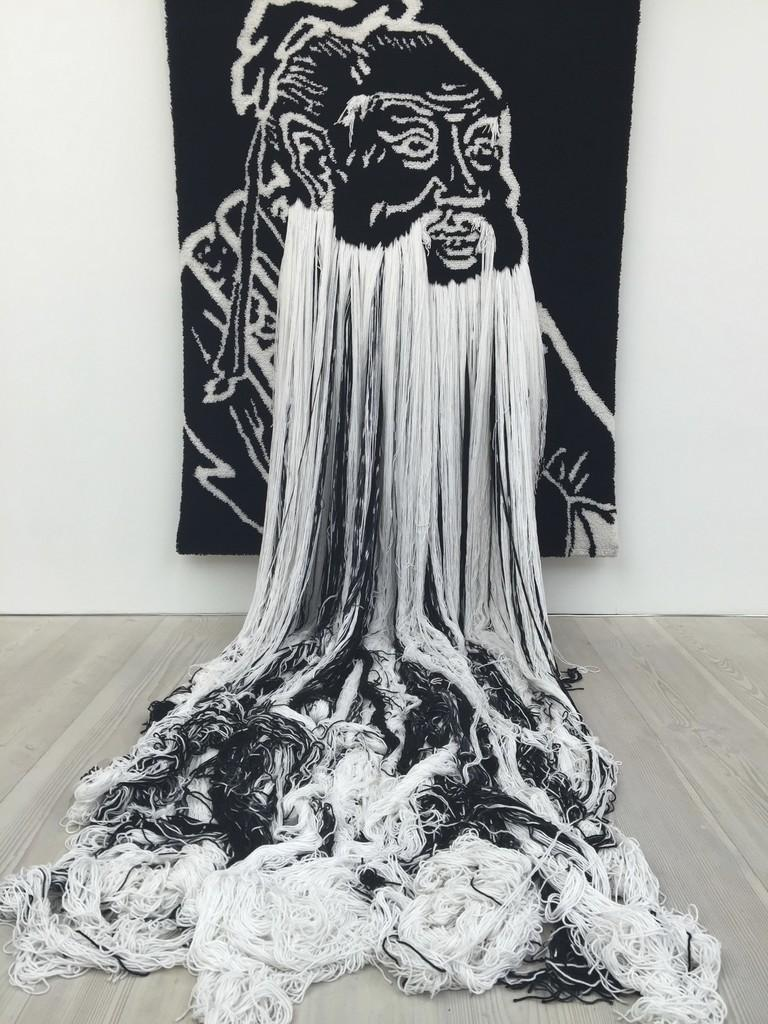What is the main subject of the image? There is an art piece on a cloth in the image. What can be seen in the background of the image? There is a wall in the background of the image. What is present on the floor in the image? There are threads on the floor in the image. How many clams are visible in the image? There are no clams present in the image. What message of peace can be seen in the art piece? The image does not depict any specific message of peace, as it only shows an art piece on a cloth and threads on the floor. 